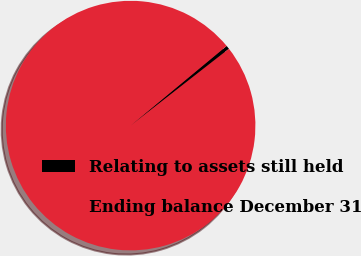Convert chart. <chart><loc_0><loc_0><loc_500><loc_500><pie_chart><fcel>Relating to assets still held<fcel>Ending balance December 31<nl><fcel>0.47%<fcel>99.53%<nl></chart> 